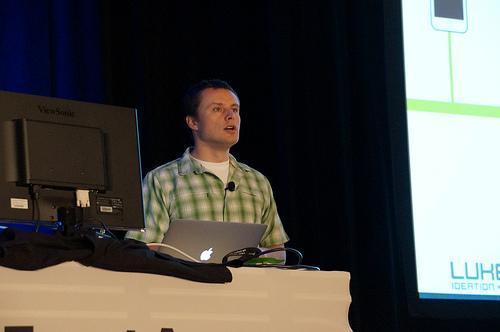How many men are there?
Give a very brief answer. 1. 